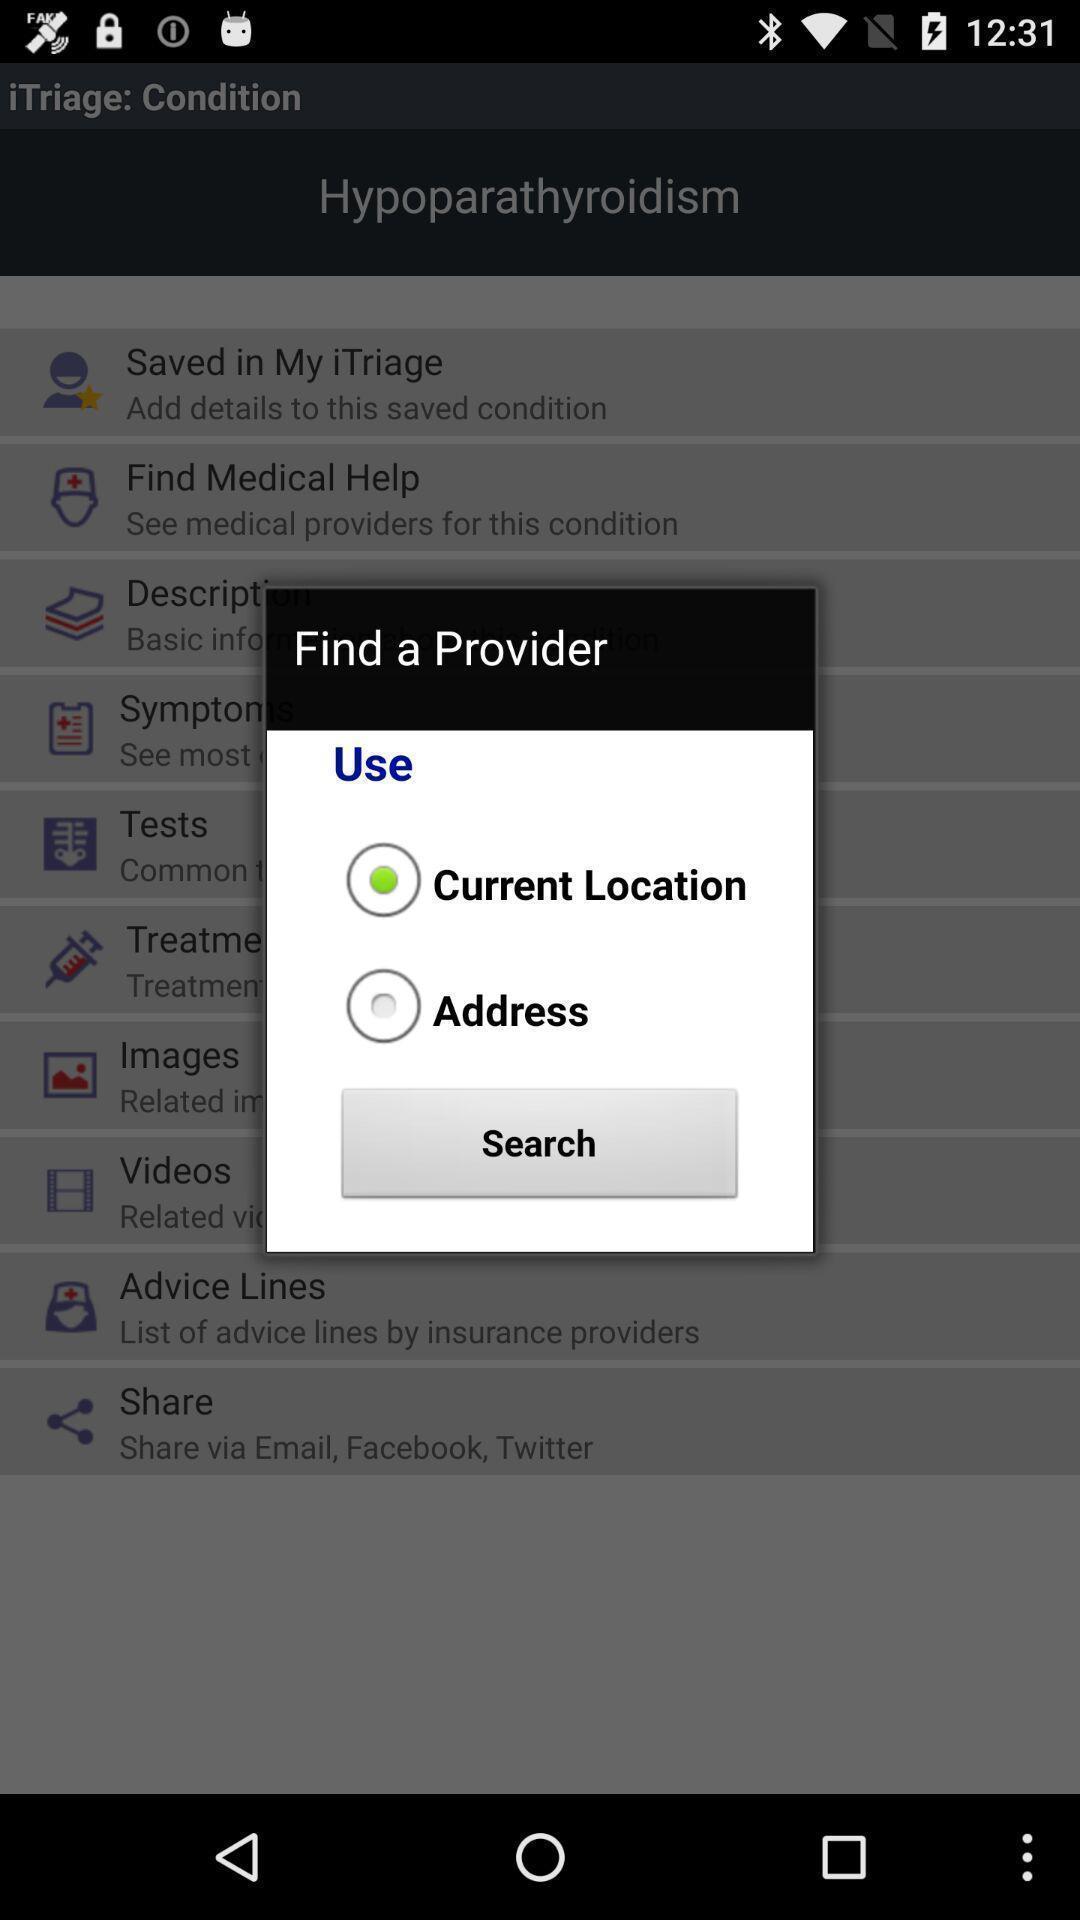Give me a narrative description of this picture. Pop-up shows find provider with given options. 